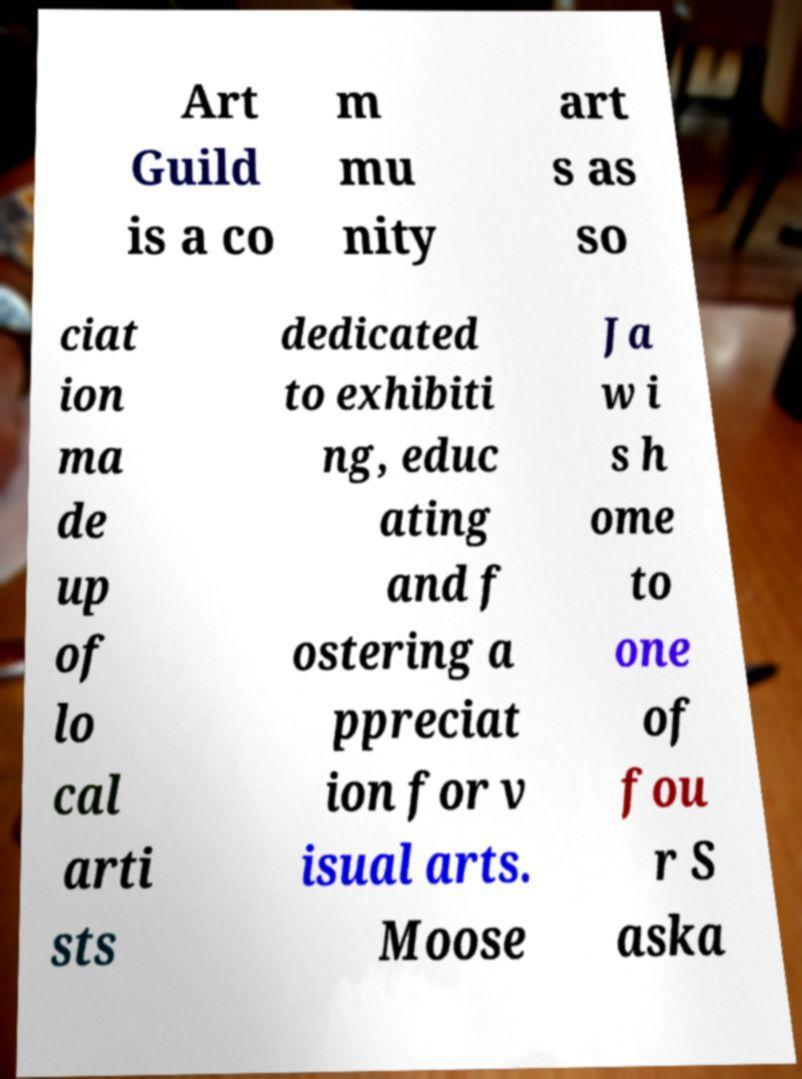Could you extract and type out the text from this image? Art Guild is a co m mu nity art s as so ciat ion ma de up of lo cal arti sts dedicated to exhibiti ng, educ ating and f ostering a ppreciat ion for v isual arts. Moose Ja w i s h ome to one of fou r S aska 